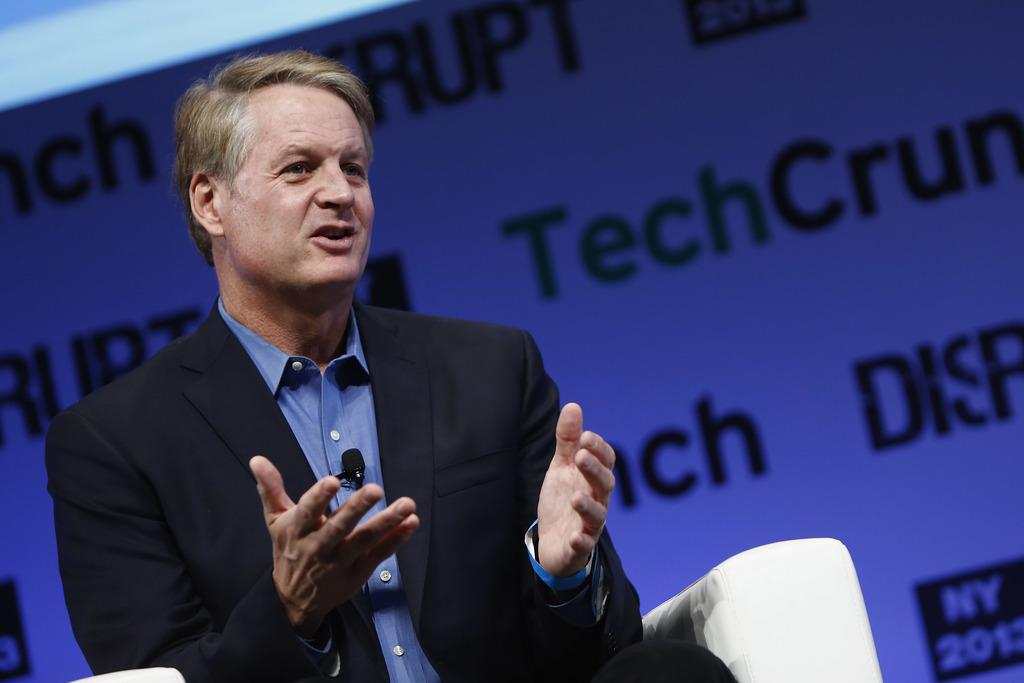What is the person in the image wearing? The person in the image is wearing a suit. What is the person doing in the image? The person is sitting and speaking. What can be seen in the background of the image? There is a banner in the background of the image. What type of flesh can be seen on the person's body in the image? There is no flesh visible on the person's body in the image, as they are fully clothed in a suit. Is the person swimming in the image? No, the person is not swimming in the image; they are sitting and speaking. 